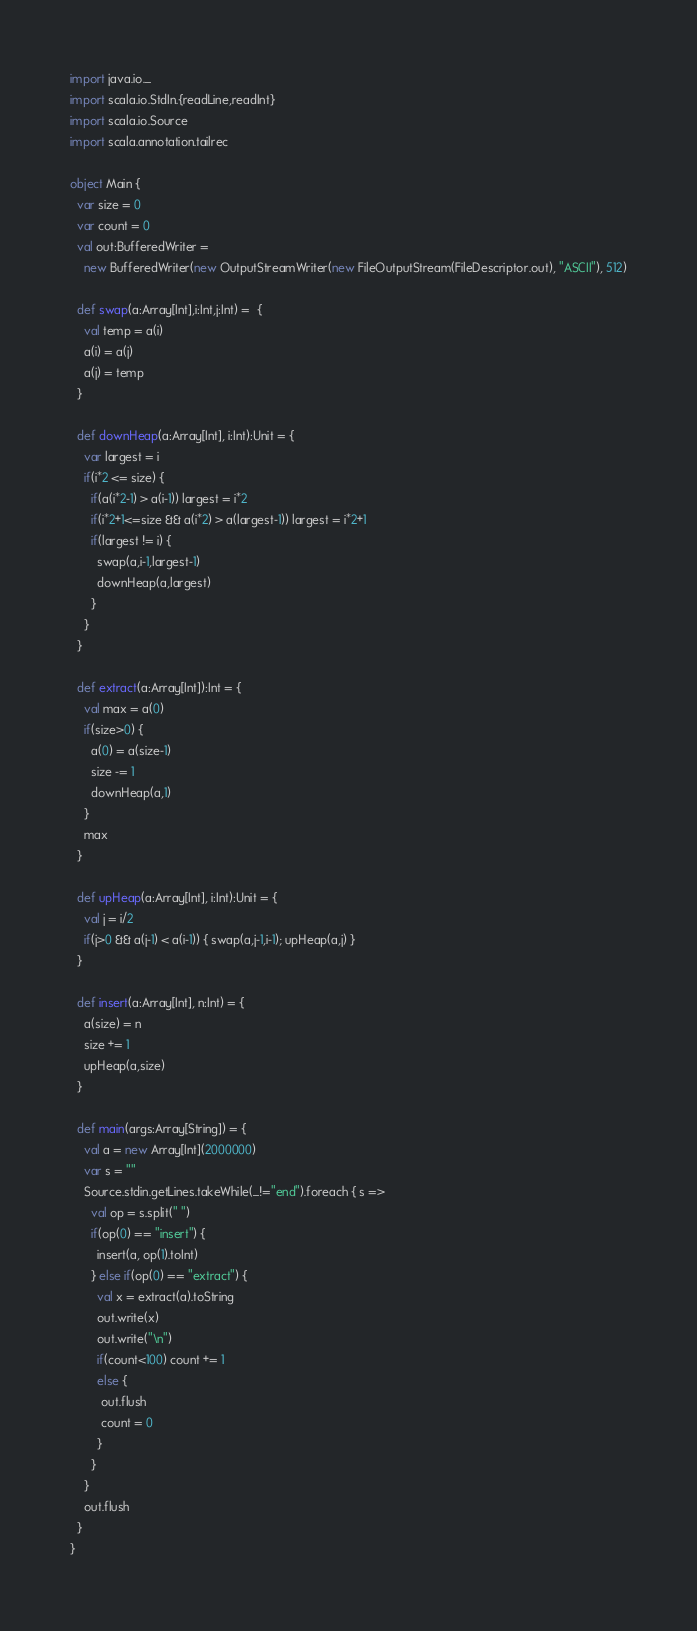Convert code to text. <code><loc_0><loc_0><loc_500><loc_500><_Scala_>import java.io._
import scala.io.StdIn.{readLine,readInt}
import scala.io.Source
import scala.annotation.tailrec

object Main {
  var size = 0
  var count = 0
  val out:BufferedWriter =
    new BufferedWriter(new OutputStreamWriter(new FileOutputStream(FileDescriptor.out), "ASCII"), 512)

  def swap(a:Array[Int],i:Int,j:Int) =  {
    val temp = a(i)
    a(i) = a(j)
    a(j) = temp
  }

  def downHeap(a:Array[Int], i:Int):Unit = {
    var largest = i
    if(i*2 <= size) {
      if(a(i*2-1) > a(i-1)) largest = i*2
      if(i*2+1<=size && a(i*2) > a(largest-1)) largest = i*2+1
      if(largest != i) {
        swap(a,i-1,largest-1)
        downHeap(a,largest)
      }
    }
  }

  def extract(a:Array[Int]):Int = {
    val max = a(0)
    if(size>0) {
      a(0) = a(size-1)
      size -= 1
      downHeap(a,1)
    }
    max
  }

  def upHeap(a:Array[Int], i:Int):Unit = {
    val j = i/2
    if(j>0 && a(j-1) < a(i-1)) { swap(a,j-1,i-1); upHeap(a,j) }
  }

  def insert(a:Array[Int], n:Int) = {
    a(size) = n
    size += 1
    upHeap(a,size)
  }

  def main(args:Array[String]) = {
    val a = new Array[Int](2000000)
    var s = ""
    Source.stdin.getLines.takeWhile(_!="end").foreach { s =>
      val op = s.split(" ")
      if(op(0) == "insert") {
        insert(a, op(1).toInt)
      } else if(op(0) == "extract") {
        val x = extract(a).toString
        out.write(x)
        out.write("\n")
        if(count<100) count += 1
        else {
         out.flush
         count = 0
        }
      }
    }
    out.flush
  }
}</code> 